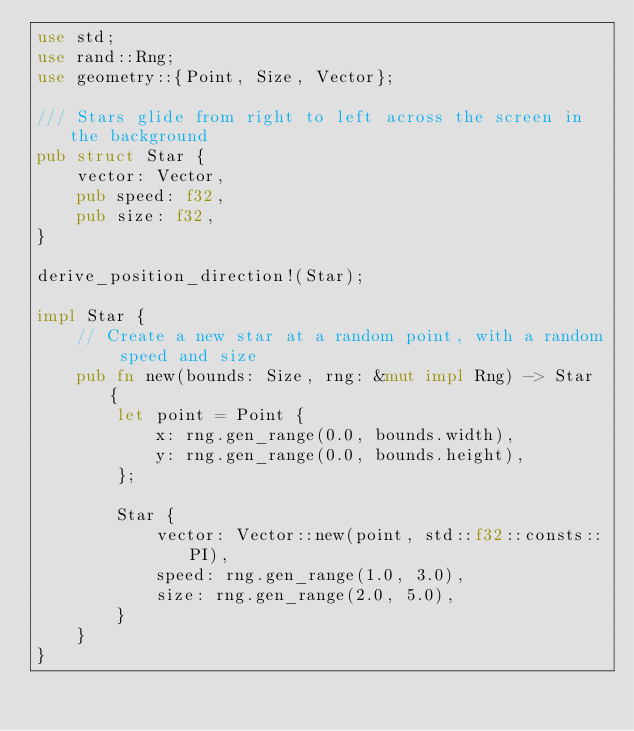<code> <loc_0><loc_0><loc_500><loc_500><_Rust_>use std;
use rand::Rng;
use geometry::{Point, Size, Vector};

/// Stars glide from right to left across the screen in the background
pub struct Star {
    vector: Vector,
    pub speed: f32,
    pub size: f32,
}

derive_position_direction!(Star);

impl Star {
    // Create a new star at a random point, with a random speed and size
    pub fn new(bounds: Size, rng: &mut impl Rng) -> Star {
        let point = Point {
            x: rng.gen_range(0.0, bounds.width),
            y: rng.gen_range(0.0, bounds.height),
        };

        Star {
            vector: Vector::new(point, std::f32::consts::PI),
            speed: rng.gen_range(1.0, 3.0),
            size: rng.gen_range(2.0, 5.0),
        }
    }
}
</code> 